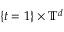Convert formula to latex. <formula><loc_0><loc_0><loc_500><loc_500>\{ t = 1 \} \times { \mathbb { T } } ^ { d }</formula> 